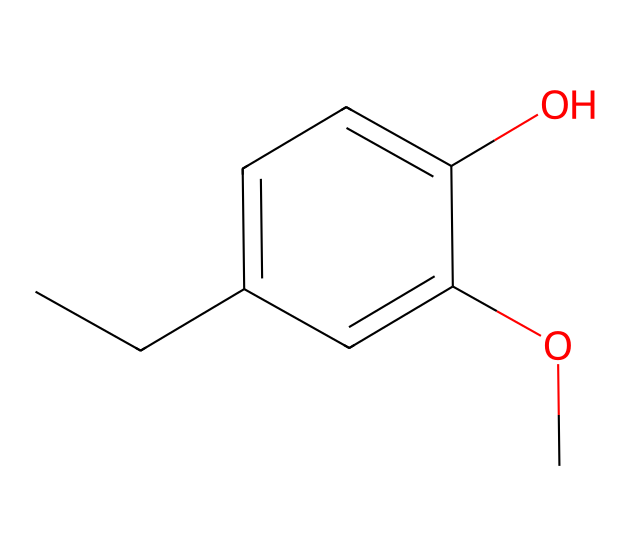What is the molecular formula of eugenol? The molecular formula can be derived from the SMILES representation by counting the different types of atoms present. In the given SMILES, we have 10 carbon atoms, 12 hydrogen atoms, and 2 oxygen atoms, leading to the molecular formula C10H12O2.
Answer: C10H12O2 How many hydroxyl groups are present in eugenol? Eugenol contains a hydroxyl group (-OH), which can be identified by looking for the "O" directly bonded to a carbon ring or chain in its structure. In this case, there is only one hydroxyl group in the phenolic structure of eugenol.
Answer: one What is the role of the methoxy group in eugenol? The methoxy group (-OCH3) plays a significant role in the electron-donating character of eugenol, which enhances its reactivity and stability as a phenol. The presence of the methoxy group affects the acidity and reactivity of the hydroxyl group.
Answer: electron-donating How many double bonds are in the eugenol structure? To determine the number of double bonds, examine the connections between carbon atoms in the SMILES representation. In eugenol, there are no explicitly stated double bonds, as all double bonds are part of the aromatic ring structure. Therefore, there are three double bonds in the cyclohexene structure.
Answer: three What type of functional groups does eugenol have? Eugenol contains two functional groups: a phenolic hydroxyl group and a methoxy group. The structure can be analyzed by identifying groups attached to the carbon framework; the -OH identifies the phenolic part and -OCH3 identifies the methoxy.
Answer: phenolic and methoxy How does the structure of eugenol compare to simple alcohols? When comparing eugenol to simple alcohols, eugenol has an additional aromatic ring, which alters its properties and reactivity compared to aliphatic alcohols that only contain carbon chains. The presence of both a phenolic hydroxyl and an aromatic system differentiates it from simple alcohols.
Answer: phenolic What is the primary use of eugenol in traditional medicine? Eugenol is primarily used for its analgesic and antiseptic properties, making it useful in dental practices and traditional remedies for pain relief. The activity can be traced through its molecular structure influencing biological interactions.
Answer: analgesic and antiseptic 